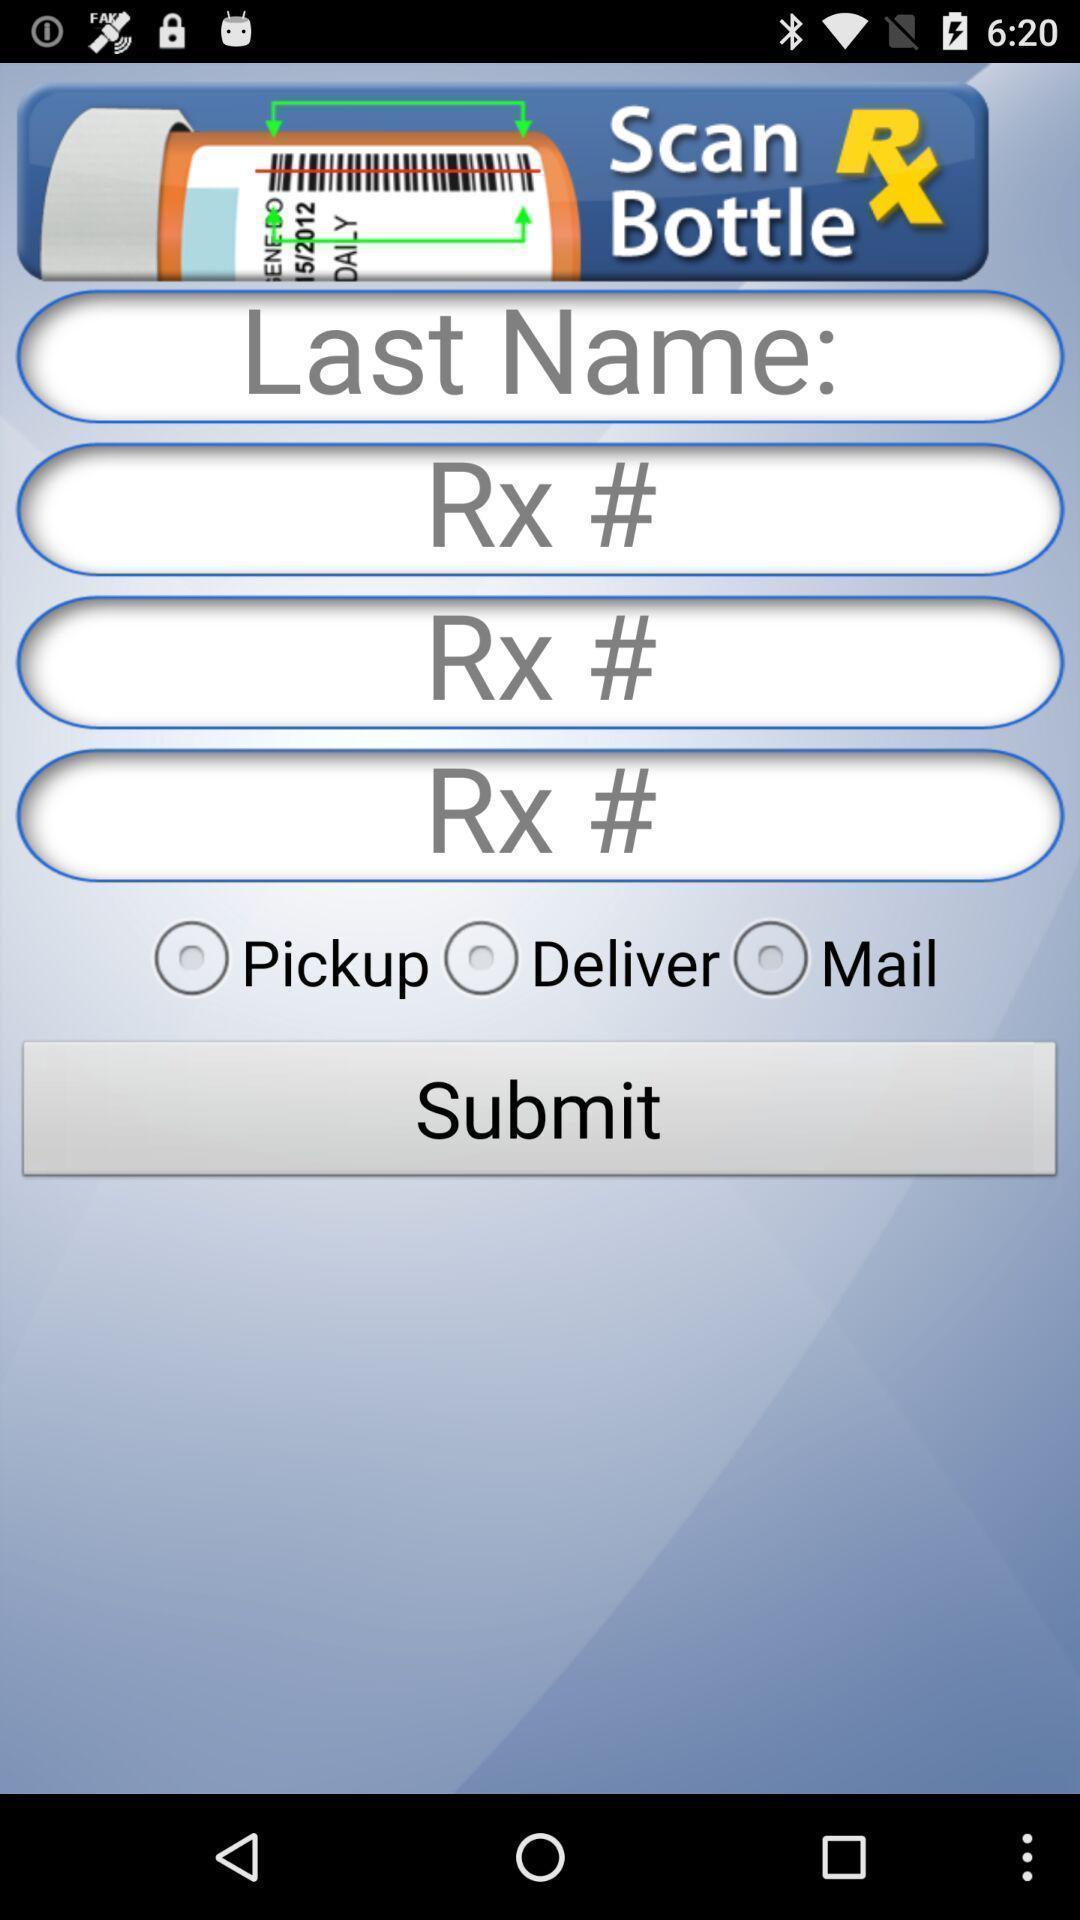What can you discern from this picture? Screen displaying the screen of pharmacy app. 